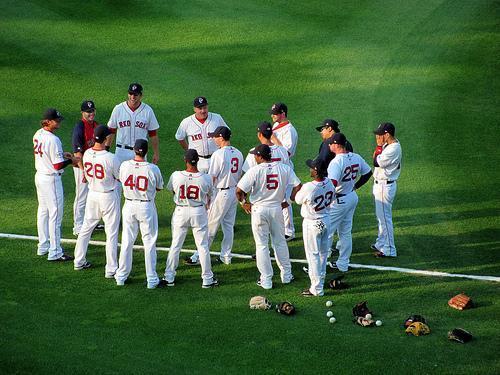How many balls are there?
Give a very brief answer. 5. 